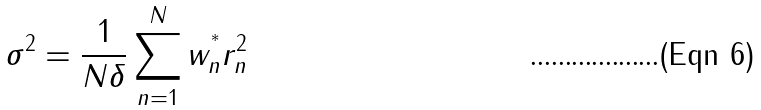Convert formula to latex. <formula><loc_0><loc_0><loc_500><loc_500>\sigma ^ { 2 } = \frac { 1 } { N \delta } \sum _ { n = 1 } ^ { N } w ^ { ^ { * } } _ { n } r _ { n } ^ { 2 }</formula> 